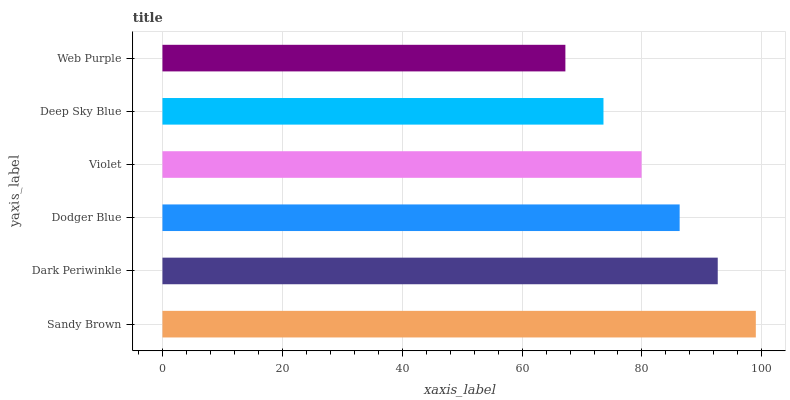Is Web Purple the minimum?
Answer yes or no. Yes. Is Sandy Brown the maximum?
Answer yes or no. Yes. Is Dark Periwinkle the minimum?
Answer yes or no. No. Is Dark Periwinkle the maximum?
Answer yes or no. No. Is Sandy Brown greater than Dark Periwinkle?
Answer yes or no. Yes. Is Dark Periwinkle less than Sandy Brown?
Answer yes or no. Yes. Is Dark Periwinkle greater than Sandy Brown?
Answer yes or no. No. Is Sandy Brown less than Dark Periwinkle?
Answer yes or no. No. Is Dodger Blue the high median?
Answer yes or no. Yes. Is Violet the low median?
Answer yes or no. Yes. Is Sandy Brown the high median?
Answer yes or no. No. Is Web Purple the low median?
Answer yes or no. No. 